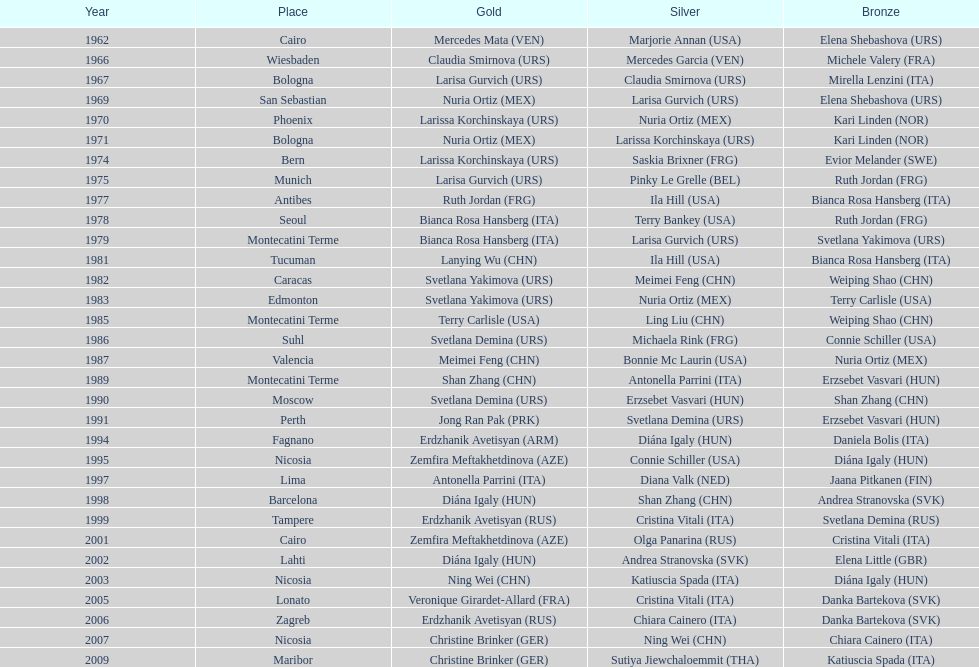Who won the only gold medal in 1962? Mercedes Mata. 